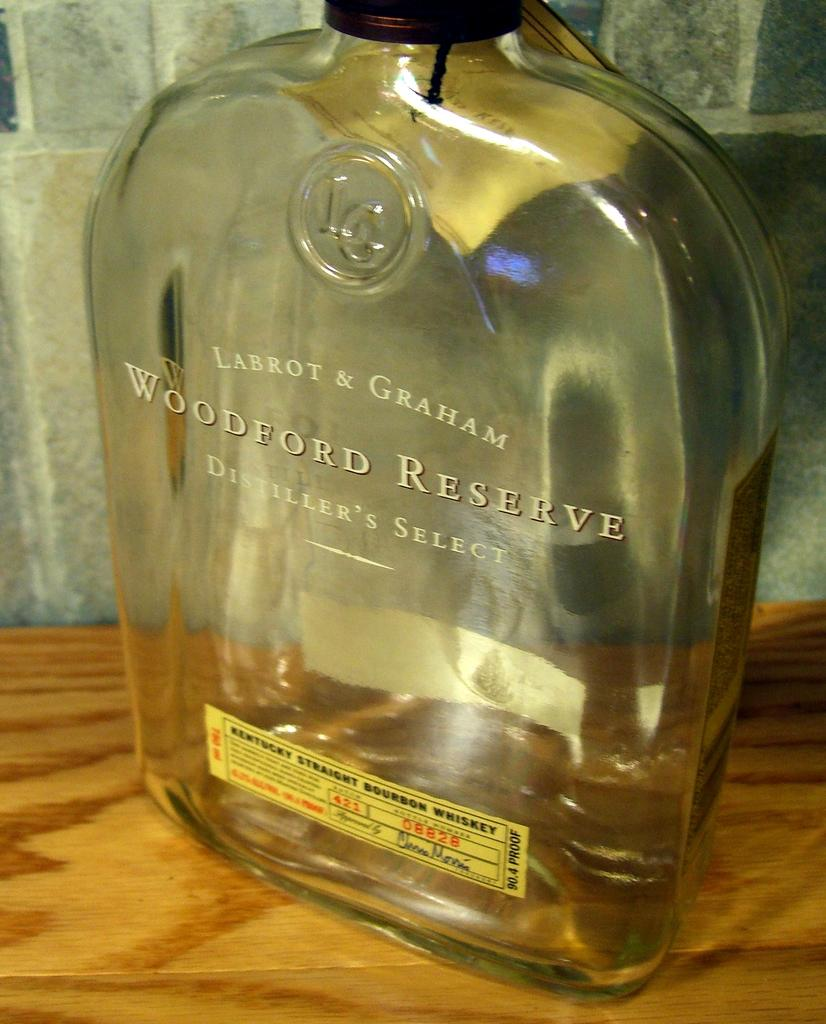What object is placed on the table in the image? There is a bottle on the table in the image. What can be seen on the bottle? The bottle has a label in front of it. What type of apparel is being worn by the bulb in the image? There is no bulb present in the image, and therefore no apparel can be associated with it. 